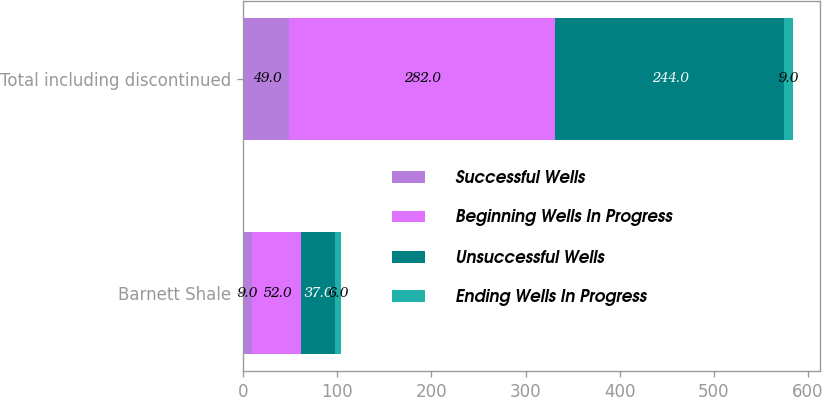<chart> <loc_0><loc_0><loc_500><loc_500><stacked_bar_chart><ecel><fcel>Barnett Shale<fcel>Total including discontinued<nl><fcel>Successful Wells<fcel>9<fcel>49<nl><fcel>Beginning Wells In Progress<fcel>52<fcel>282<nl><fcel>Unsuccessful Wells<fcel>37<fcel>244<nl><fcel>Ending Wells In Progress<fcel>6<fcel>9<nl></chart> 